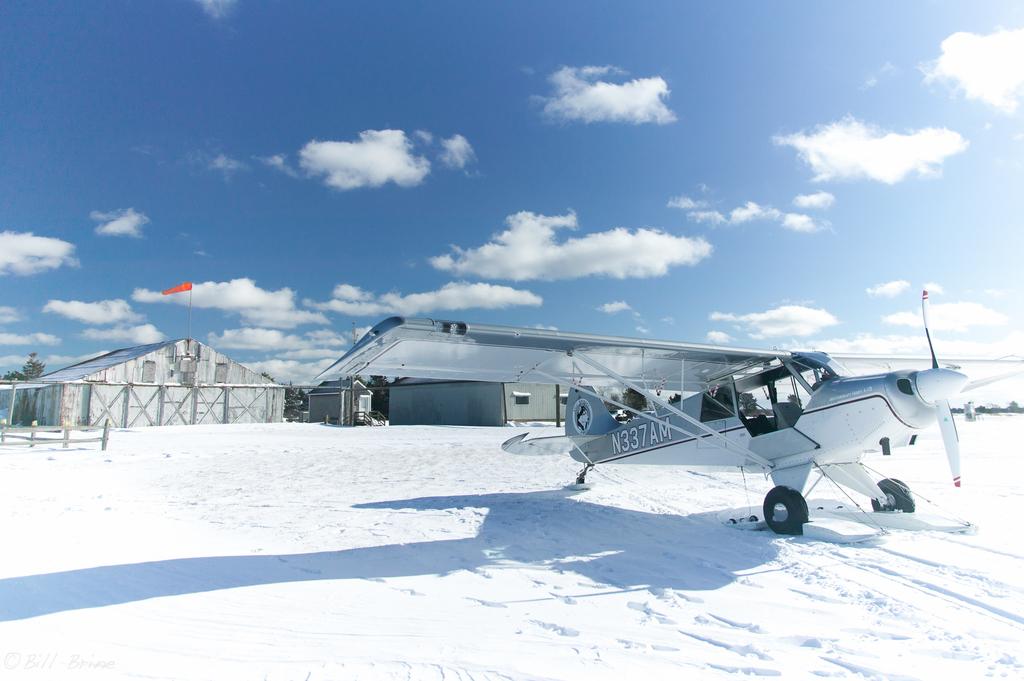What are the numbers on the plane?
Make the answer very short. N337am. 